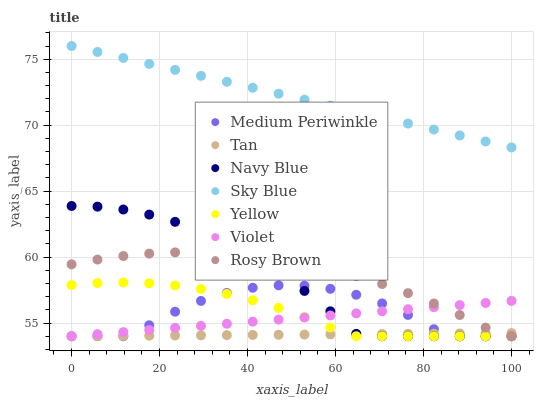Does Tan have the minimum area under the curve?
Answer yes or no. Yes. Does Sky Blue have the maximum area under the curve?
Answer yes or no. Yes. Does Rosy Brown have the minimum area under the curve?
Answer yes or no. No. Does Rosy Brown have the maximum area under the curve?
Answer yes or no. No. Is Tan the smoothest?
Answer yes or no. Yes. Is Medium Periwinkle the roughest?
Answer yes or no. Yes. Is Rosy Brown the smoothest?
Answer yes or no. No. Is Rosy Brown the roughest?
Answer yes or no. No. Does Navy Blue have the lowest value?
Answer yes or no. Yes. Does Sky Blue have the lowest value?
Answer yes or no. No. Does Sky Blue have the highest value?
Answer yes or no. Yes. Does Rosy Brown have the highest value?
Answer yes or no. No. Is Navy Blue less than Sky Blue?
Answer yes or no. Yes. Is Sky Blue greater than Tan?
Answer yes or no. Yes. Does Medium Periwinkle intersect Yellow?
Answer yes or no. Yes. Is Medium Periwinkle less than Yellow?
Answer yes or no. No. Is Medium Periwinkle greater than Yellow?
Answer yes or no. No. Does Navy Blue intersect Sky Blue?
Answer yes or no. No. 